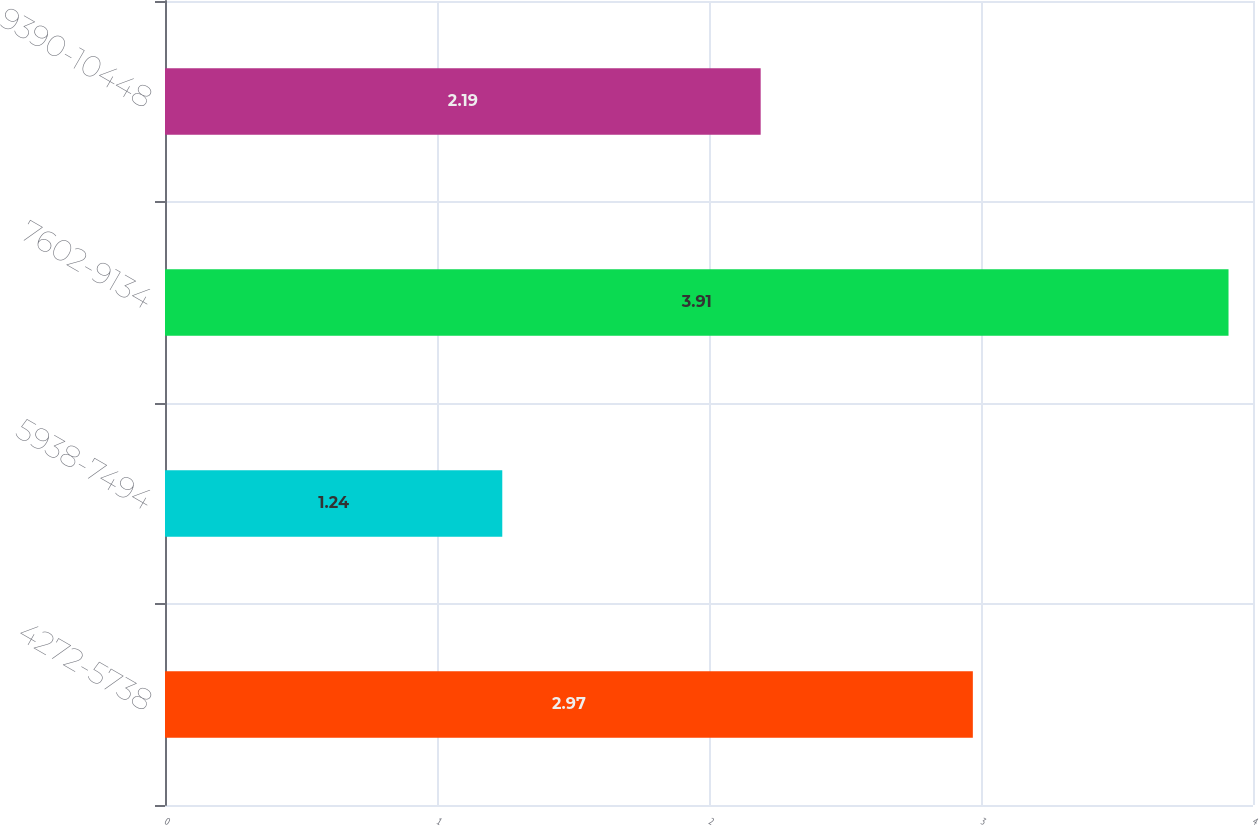Convert chart. <chart><loc_0><loc_0><loc_500><loc_500><bar_chart><fcel>4272-5738<fcel>5938-7494<fcel>7602-9134<fcel>9390-10448<nl><fcel>2.97<fcel>1.24<fcel>3.91<fcel>2.19<nl></chart> 